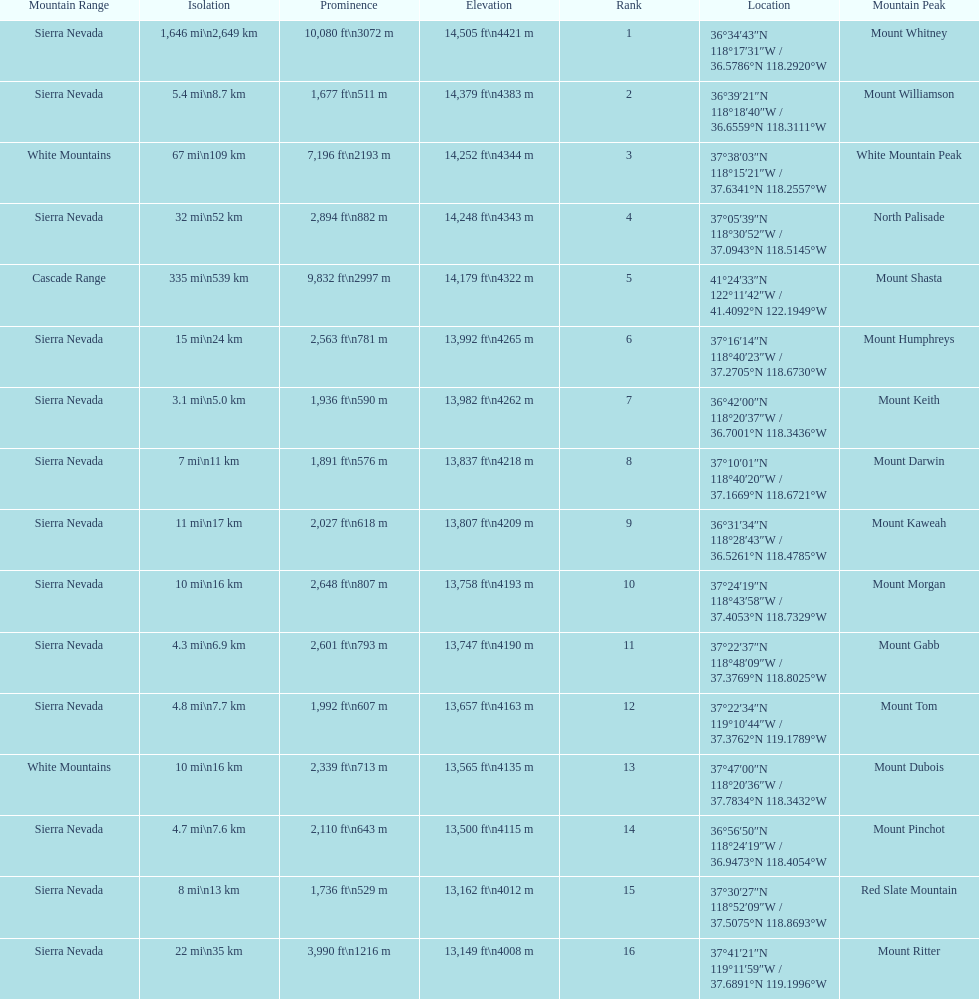What is the total elevation (in ft) of mount whitney? 14,505 ft. Write the full table. {'header': ['Mountain Range', 'Isolation', 'Prominence', 'Elevation', 'Rank', 'Location', 'Mountain Peak'], 'rows': [['Sierra Nevada', '1,646\xa0mi\\n2,649\xa0km', '10,080\xa0ft\\n3072\xa0m', '14,505\xa0ft\\n4421\xa0m', '1', '36°34′43″N 118°17′31″W\ufeff / \ufeff36.5786°N 118.2920°W', 'Mount Whitney'], ['Sierra Nevada', '5.4\xa0mi\\n8.7\xa0km', '1,677\xa0ft\\n511\xa0m', '14,379\xa0ft\\n4383\xa0m', '2', '36°39′21″N 118°18′40″W\ufeff / \ufeff36.6559°N 118.3111°W', 'Mount Williamson'], ['White Mountains', '67\xa0mi\\n109\xa0km', '7,196\xa0ft\\n2193\xa0m', '14,252\xa0ft\\n4344\xa0m', '3', '37°38′03″N 118°15′21″W\ufeff / \ufeff37.6341°N 118.2557°W', 'White Mountain Peak'], ['Sierra Nevada', '32\xa0mi\\n52\xa0km', '2,894\xa0ft\\n882\xa0m', '14,248\xa0ft\\n4343\xa0m', '4', '37°05′39″N 118°30′52″W\ufeff / \ufeff37.0943°N 118.5145°W', 'North Palisade'], ['Cascade Range', '335\xa0mi\\n539\xa0km', '9,832\xa0ft\\n2997\xa0m', '14,179\xa0ft\\n4322\xa0m', '5', '41°24′33″N 122°11′42″W\ufeff / \ufeff41.4092°N 122.1949°W', 'Mount Shasta'], ['Sierra Nevada', '15\xa0mi\\n24\xa0km', '2,563\xa0ft\\n781\xa0m', '13,992\xa0ft\\n4265\xa0m', '6', '37°16′14″N 118°40′23″W\ufeff / \ufeff37.2705°N 118.6730°W', 'Mount Humphreys'], ['Sierra Nevada', '3.1\xa0mi\\n5.0\xa0km', '1,936\xa0ft\\n590\xa0m', '13,982\xa0ft\\n4262\xa0m', '7', '36°42′00″N 118°20′37″W\ufeff / \ufeff36.7001°N 118.3436°W', 'Mount Keith'], ['Sierra Nevada', '7\xa0mi\\n11\xa0km', '1,891\xa0ft\\n576\xa0m', '13,837\xa0ft\\n4218\xa0m', '8', '37°10′01″N 118°40′20″W\ufeff / \ufeff37.1669°N 118.6721°W', 'Mount Darwin'], ['Sierra Nevada', '11\xa0mi\\n17\xa0km', '2,027\xa0ft\\n618\xa0m', '13,807\xa0ft\\n4209\xa0m', '9', '36°31′34″N 118°28′43″W\ufeff / \ufeff36.5261°N 118.4785°W', 'Mount Kaweah'], ['Sierra Nevada', '10\xa0mi\\n16\xa0km', '2,648\xa0ft\\n807\xa0m', '13,758\xa0ft\\n4193\xa0m', '10', '37°24′19″N 118°43′58″W\ufeff / \ufeff37.4053°N 118.7329°W', 'Mount Morgan'], ['Sierra Nevada', '4.3\xa0mi\\n6.9\xa0km', '2,601\xa0ft\\n793\xa0m', '13,747\xa0ft\\n4190\xa0m', '11', '37°22′37″N 118°48′09″W\ufeff / \ufeff37.3769°N 118.8025°W', 'Mount Gabb'], ['Sierra Nevada', '4.8\xa0mi\\n7.7\xa0km', '1,992\xa0ft\\n607\xa0m', '13,657\xa0ft\\n4163\xa0m', '12', '37°22′34″N 119°10′44″W\ufeff / \ufeff37.3762°N 119.1789°W', 'Mount Tom'], ['White Mountains', '10\xa0mi\\n16\xa0km', '2,339\xa0ft\\n713\xa0m', '13,565\xa0ft\\n4135\xa0m', '13', '37°47′00″N 118°20′36″W\ufeff / \ufeff37.7834°N 118.3432°W', 'Mount Dubois'], ['Sierra Nevada', '4.7\xa0mi\\n7.6\xa0km', '2,110\xa0ft\\n643\xa0m', '13,500\xa0ft\\n4115\xa0m', '14', '36°56′50″N 118°24′19″W\ufeff / \ufeff36.9473°N 118.4054°W', 'Mount Pinchot'], ['Sierra Nevada', '8\xa0mi\\n13\xa0km', '1,736\xa0ft\\n529\xa0m', '13,162\xa0ft\\n4012\xa0m', '15', '37°30′27″N 118°52′09″W\ufeff / \ufeff37.5075°N 118.8693°W', 'Red Slate Mountain'], ['Sierra Nevada', '22\xa0mi\\n35\xa0km', '3,990\xa0ft\\n1216\xa0m', '13,149\xa0ft\\n4008\xa0m', '16', '37°41′21″N 119°11′59″W\ufeff / \ufeff37.6891°N 119.1996°W', 'Mount Ritter']]} 